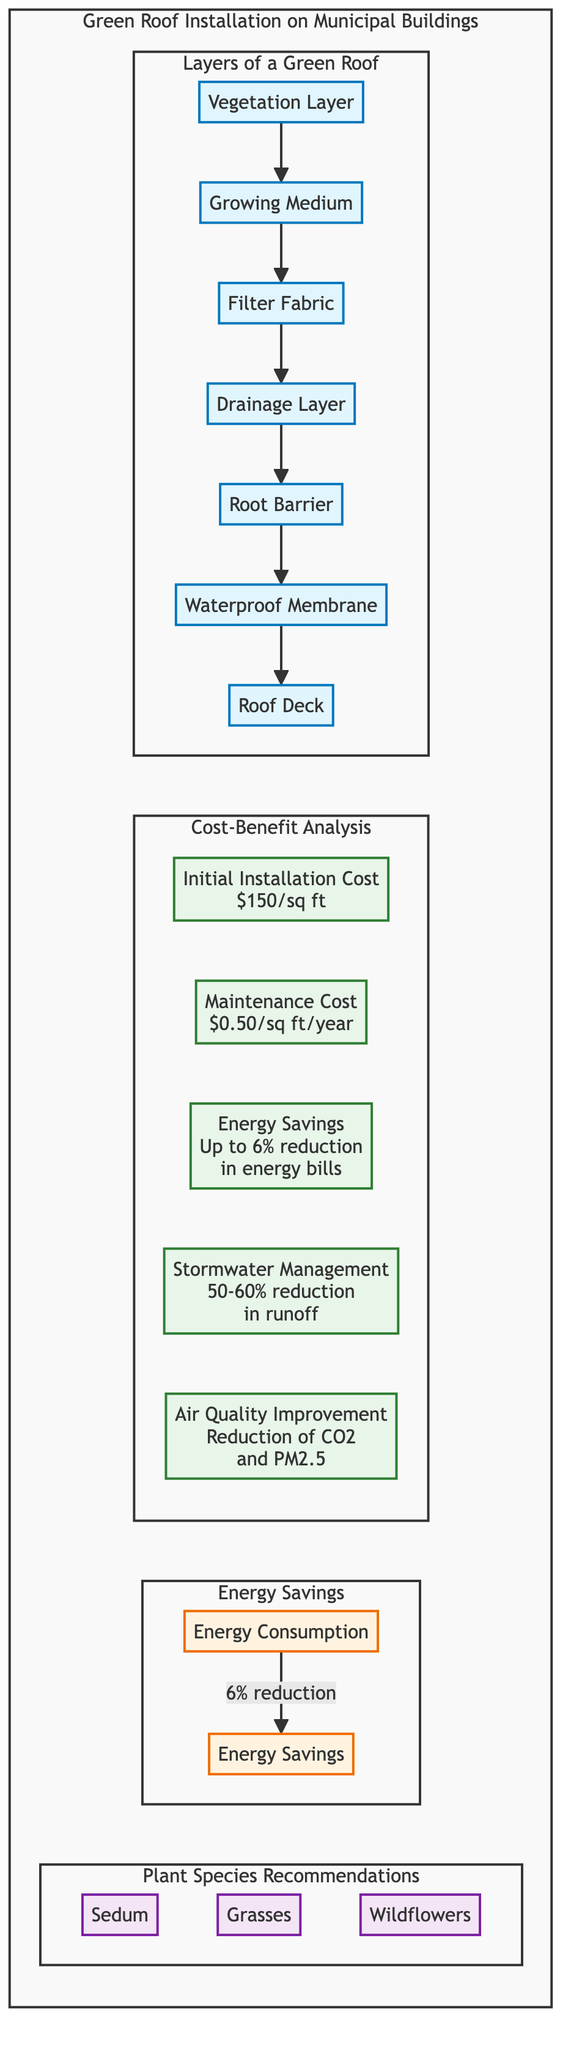What is the cost of initial installation per square foot? The diagram specifies the initial installation cost of a green roof as $150 per square foot, which is clearly indicated in the cost-benefit analysis section.
Answer: $150/sq ft How many layers are there in a green roof? Counting from the "Layers of a Green Roof" section, there are a total of 7 layers listed, starting from the Vegetation Layer down to the Roof Deck.
Answer: 7 What percentage reduction in energy bills can be achieved? The diagram states that the energy savings can be up to a 6% reduction in energy bills, based on the energy savings section.
Answer: 6% Which layer directly protects the roof from roots? The diagram indicates that the "Root Barrier" layer is directly responsible for protecting the roof deck from roots, as indicated in the layers sequence.
Answer: Root Barrier Which plant species is recommended for green roofs? The diagram lists several recommended plant species, including Sedum, Grasses, and Wildflowers, providing options for selection.
Answer: Sedum, Grasses, Wildflowers What benefit is associated with stormwater management? The cost-benefit analysis section mentions a stormwater management benefit resulting in a 50-60% reduction in runoff, highlighting the positive ecological impact.
Answer: 50-60% reduction What is the maintenance cost per square foot per year? According to the cost-benefit analysis, the maintenance cost is stated as $0.50 per square foot per year, which is clearly displayed in that section of the diagram.
Answer: $0.50/sq ft/year How does energy consumption relate to energy savings in the diagram? In the energy savings section, it shows that there is a direct relationship where energy consumption leads to a 6% reduction, thus linking the two aspects clearly.
Answer: 6% reduction What is depicted above the drainage layer? The diagram illustrates that the "Filter Fabric" is located directly above the "Drainage Layer," following the specified order of layers.
Answer: Filter Fabric 